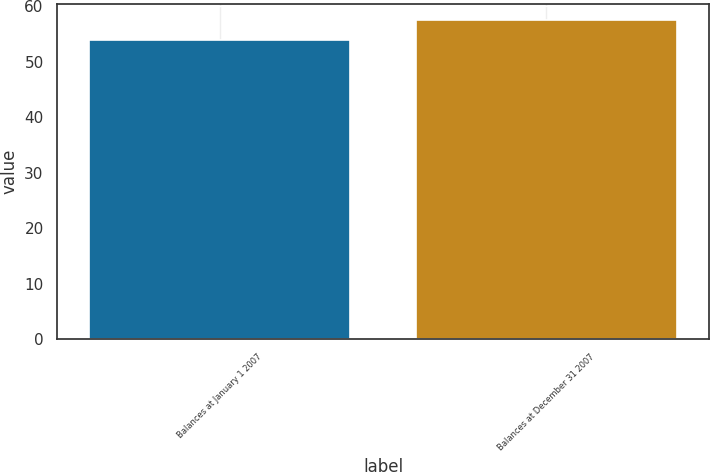Convert chart to OTSL. <chart><loc_0><loc_0><loc_500><loc_500><bar_chart><fcel>Balances at January 1 2007<fcel>Balances at December 31 2007<nl><fcel>53.9<fcel>57.6<nl></chart> 